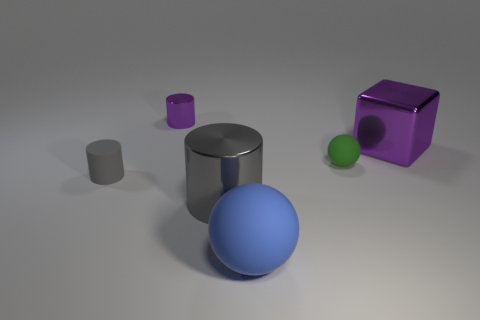Add 1 blue rubber spheres. How many objects exist? 7 Subtract all blocks. How many objects are left? 5 Add 5 purple shiny things. How many purple shiny things exist? 7 Subtract 0 brown cylinders. How many objects are left? 6 Subtract all small gray matte things. Subtract all small green rubber balls. How many objects are left? 4 Add 5 big blue spheres. How many big blue spheres are left? 6 